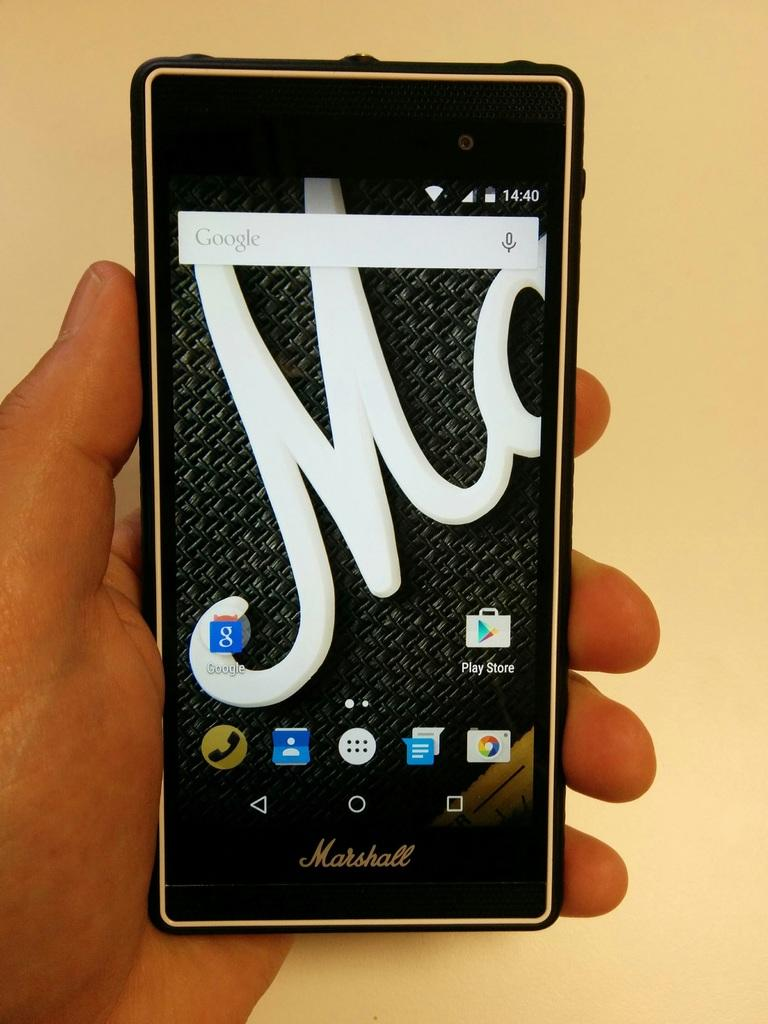<image>
Summarize the visual content of the image. A person holds a Marshall phone in their hand and the time is 14:40. 